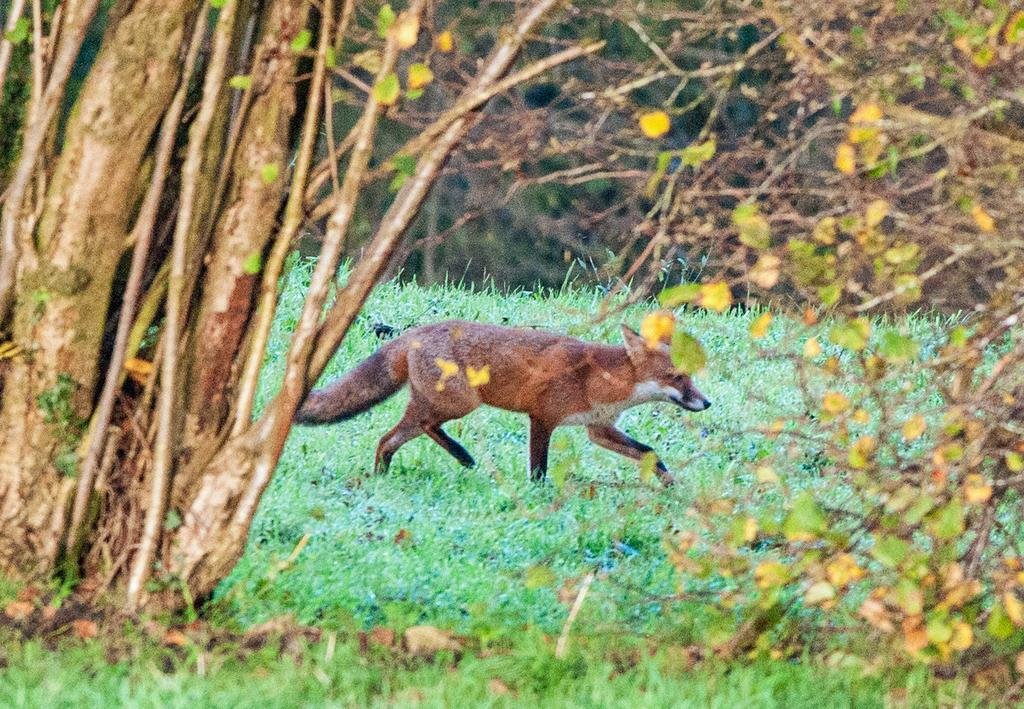What type of animal is in the image? The specific type of animal cannot be determined from the provided facts. What can be seen beneath the animal in the image? The ground is visible in the image. What type of vegetation is present on the ground? There is grass on the ground. What else can be seen in the image besides the animal and the ground? There are trees in the image. What is visible in the background of the image? The background of the image is visible. How many friends does the animal have in the image? There is no indication of friends or social interactions in the image, as it only features an animal, the ground, grass, trees, and a visible background. 